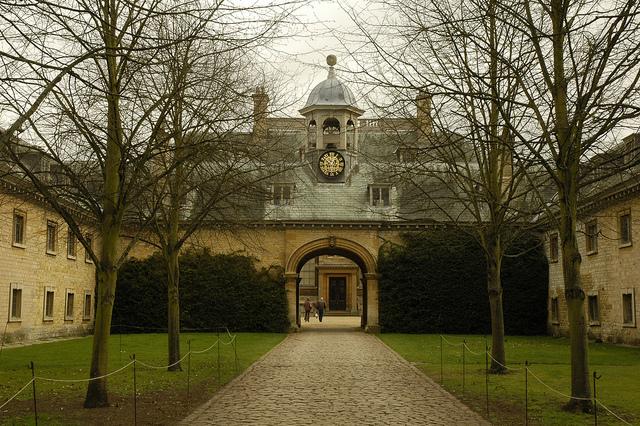What time does the clock say?
Be succinct. 2:45. Is this building newly built?
Keep it brief. No. Is this photo taken in the summertime?
Concise answer only. No. 